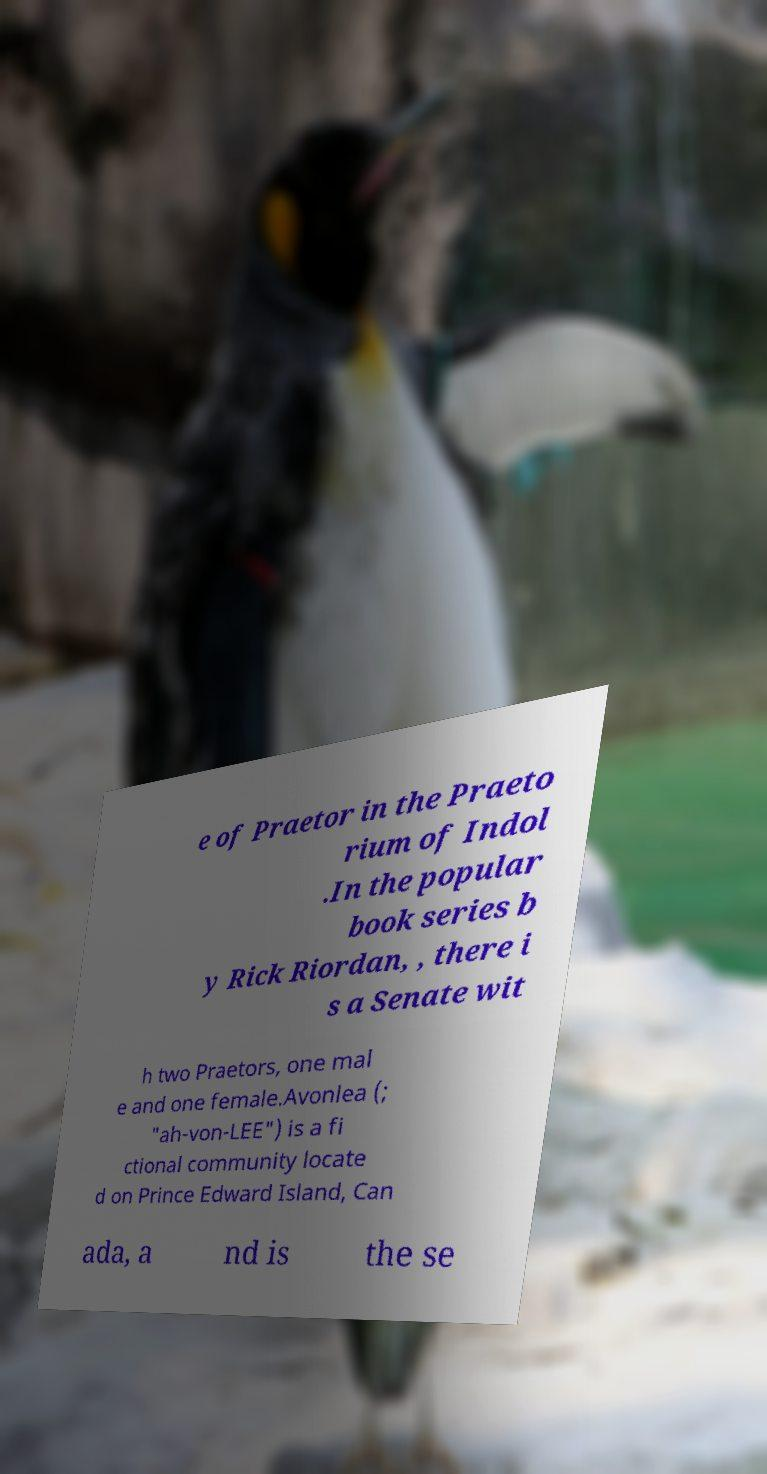Could you assist in decoding the text presented in this image and type it out clearly? e of Praetor in the Praeto rium of Indol .In the popular book series b y Rick Riordan, , there i s a Senate wit h two Praetors, one mal e and one female.Avonlea (; "ah-von-LEE") is a fi ctional community locate d on Prince Edward Island, Can ada, a nd is the se 